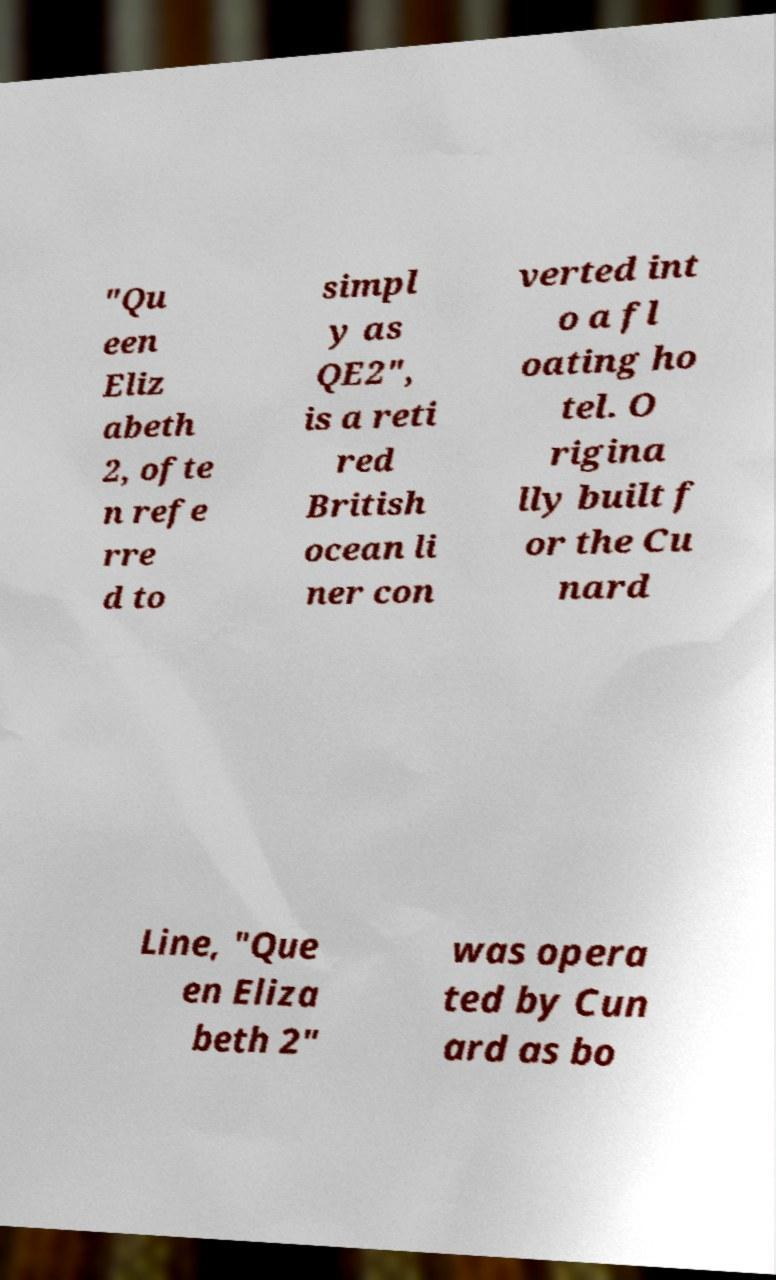Can you accurately transcribe the text from the provided image for me? "Qu een Eliz abeth 2, ofte n refe rre d to simpl y as QE2", is a reti red British ocean li ner con verted int o a fl oating ho tel. O rigina lly built f or the Cu nard Line, "Que en Eliza beth 2" was opera ted by Cun ard as bo 